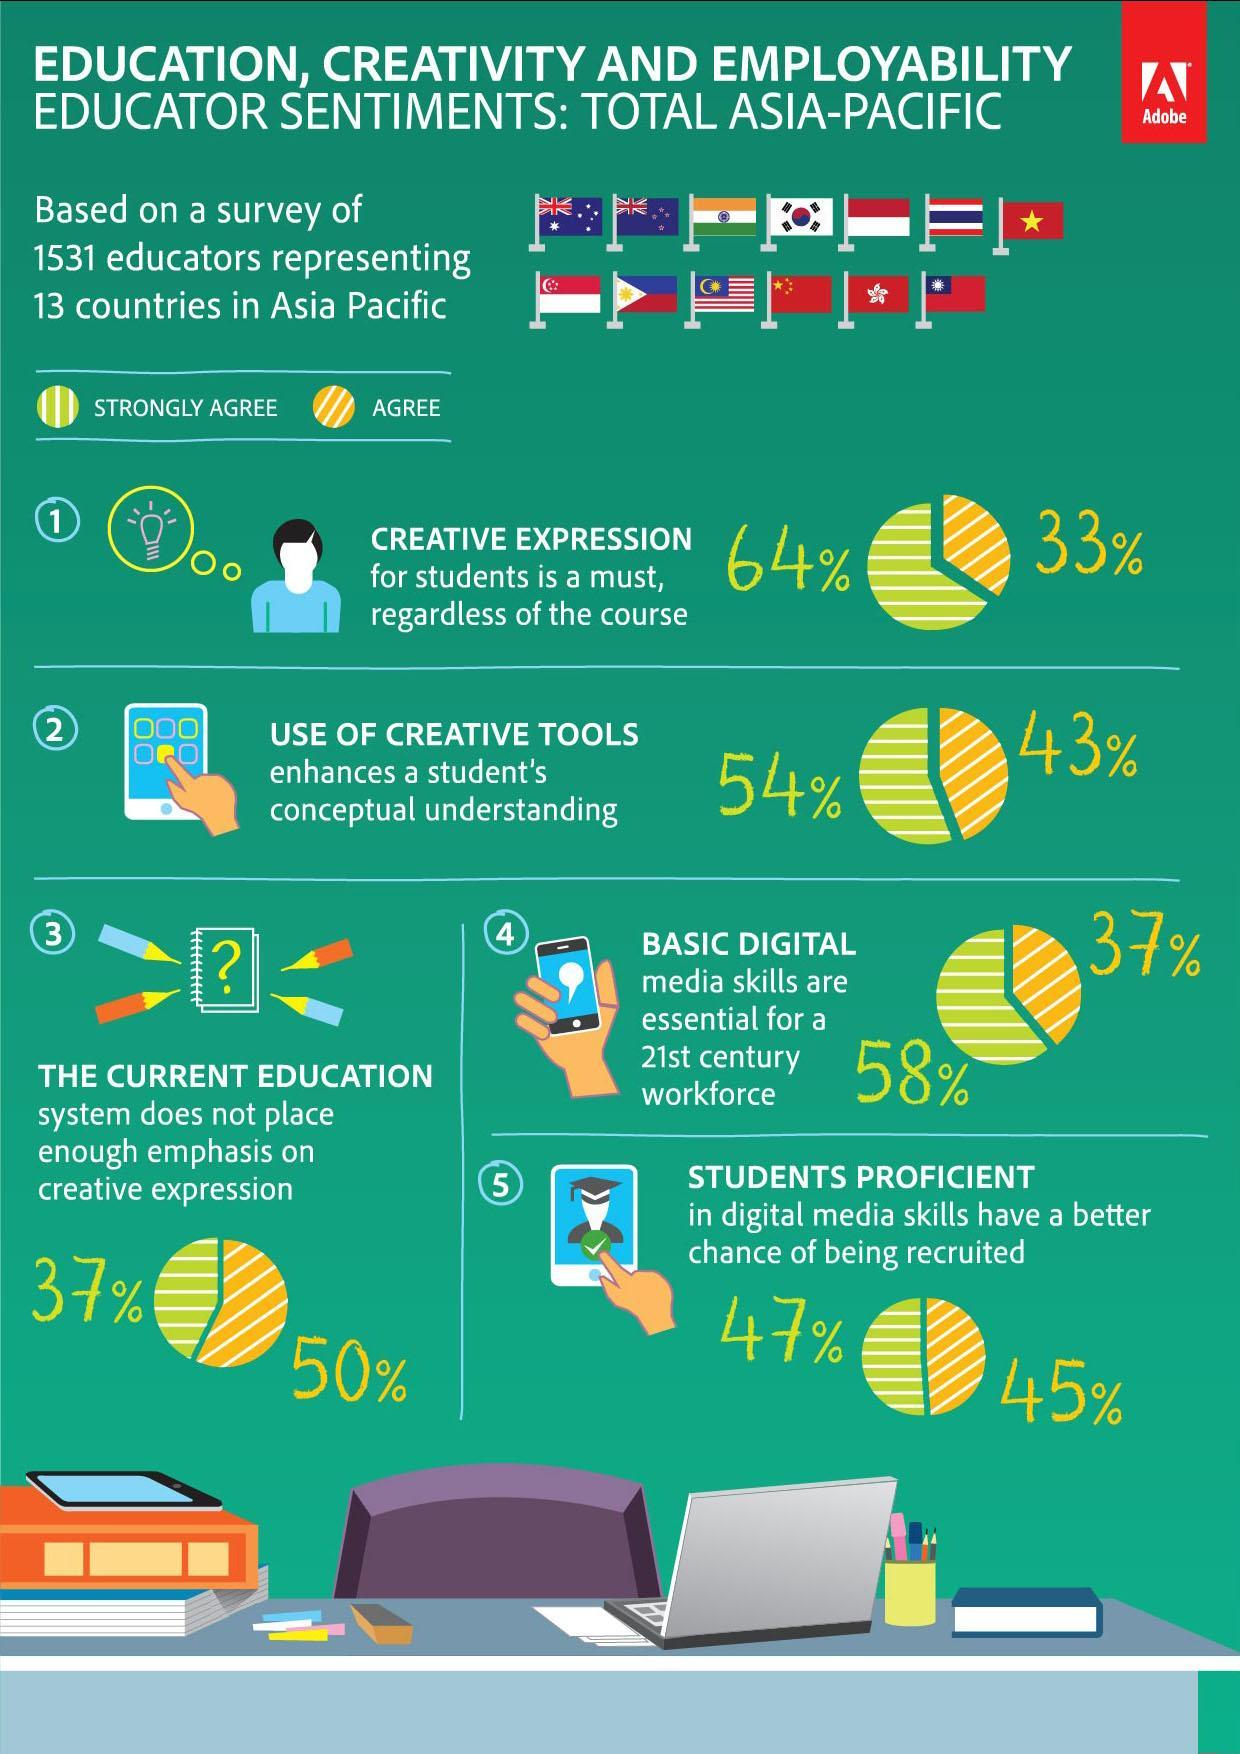What percentage of educators agree on the topic Students proficiency in digital media skills and chance of getting recruited fast?
Answer the question with a short phrase. 45% What percentage of educators have no opinion on creative expression is must for students? 3 What percentage of educators Strongly agree on the topic Students proficiency in digital media skills and chance of getting recruited fast? 47% What percentage of educators Strongly agree on use of creative tools enhances student understanding? 54% Which Asian country's flag is shown in the third position- China, Japan, India, Korea? India What percentage of educators Strongly agree on the topic Basic Digital media skill is essential for students in the current century? 58% What percentage of educators Strongly agree on the topic of current education system needs to be changed for more creative expression? 37% What percentage of educators Agree creative expression is must for students? 33% What percentage of educators agree on the topic- current education system needs to be changed for more creative expression? 50% How many questions/topics were taken into consideration for the survey? 5 